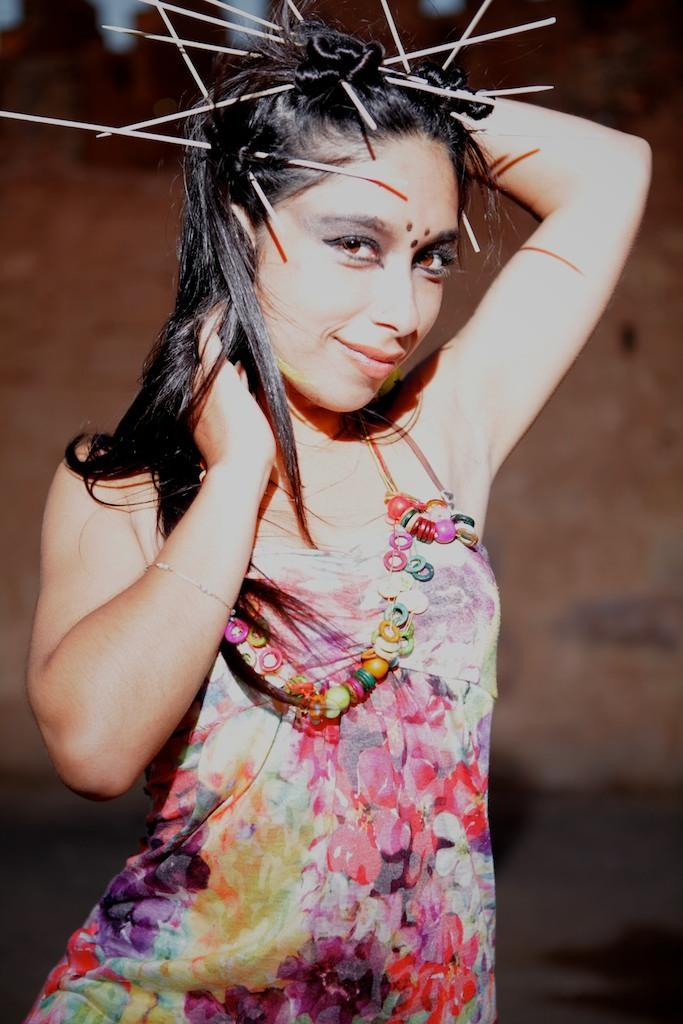Who is present in the image? There is a woman in the image. What expression does the woman have? The woman is smiling. Can you describe the background of the image? The background of the image is blurred. What expertise does the grandmother have in the image? There is no mention of a grandmother in the image, and therefore no expertise can be attributed to her. 